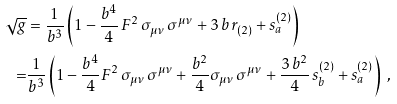Convert formula to latex. <formula><loc_0><loc_0><loc_500><loc_500>\sqrt { g } & = \frac { 1 } { b ^ { 3 } } \left ( 1 - \frac { b ^ { 4 } } { 4 } \, F ^ { 2 } \, \sigma _ { \mu \nu } \, \sigma ^ { \mu \nu } + 3 \, b \, r _ { ( 2 ) } + s _ { a } ^ { ( 2 ) } \right ) \\ = & \frac { 1 } { b ^ { 3 } } \left ( 1 - \frac { b ^ { 4 } } { 4 } F ^ { 2 } \, \sigma _ { \mu \nu } \, \sigma ^ { \mu \nu } + \frac { b ^ { 2 } } { 4 } \sigma _ { \mu \nu } \, \sigma ^ { \mu \nu } + \frac { 3 \, b ^ { 2 } } { 4 } \, s _ { b } ^ { ( 2 ) } + s _ { a } ^ { ( 2 ) } \right ) \ ,</formula> 